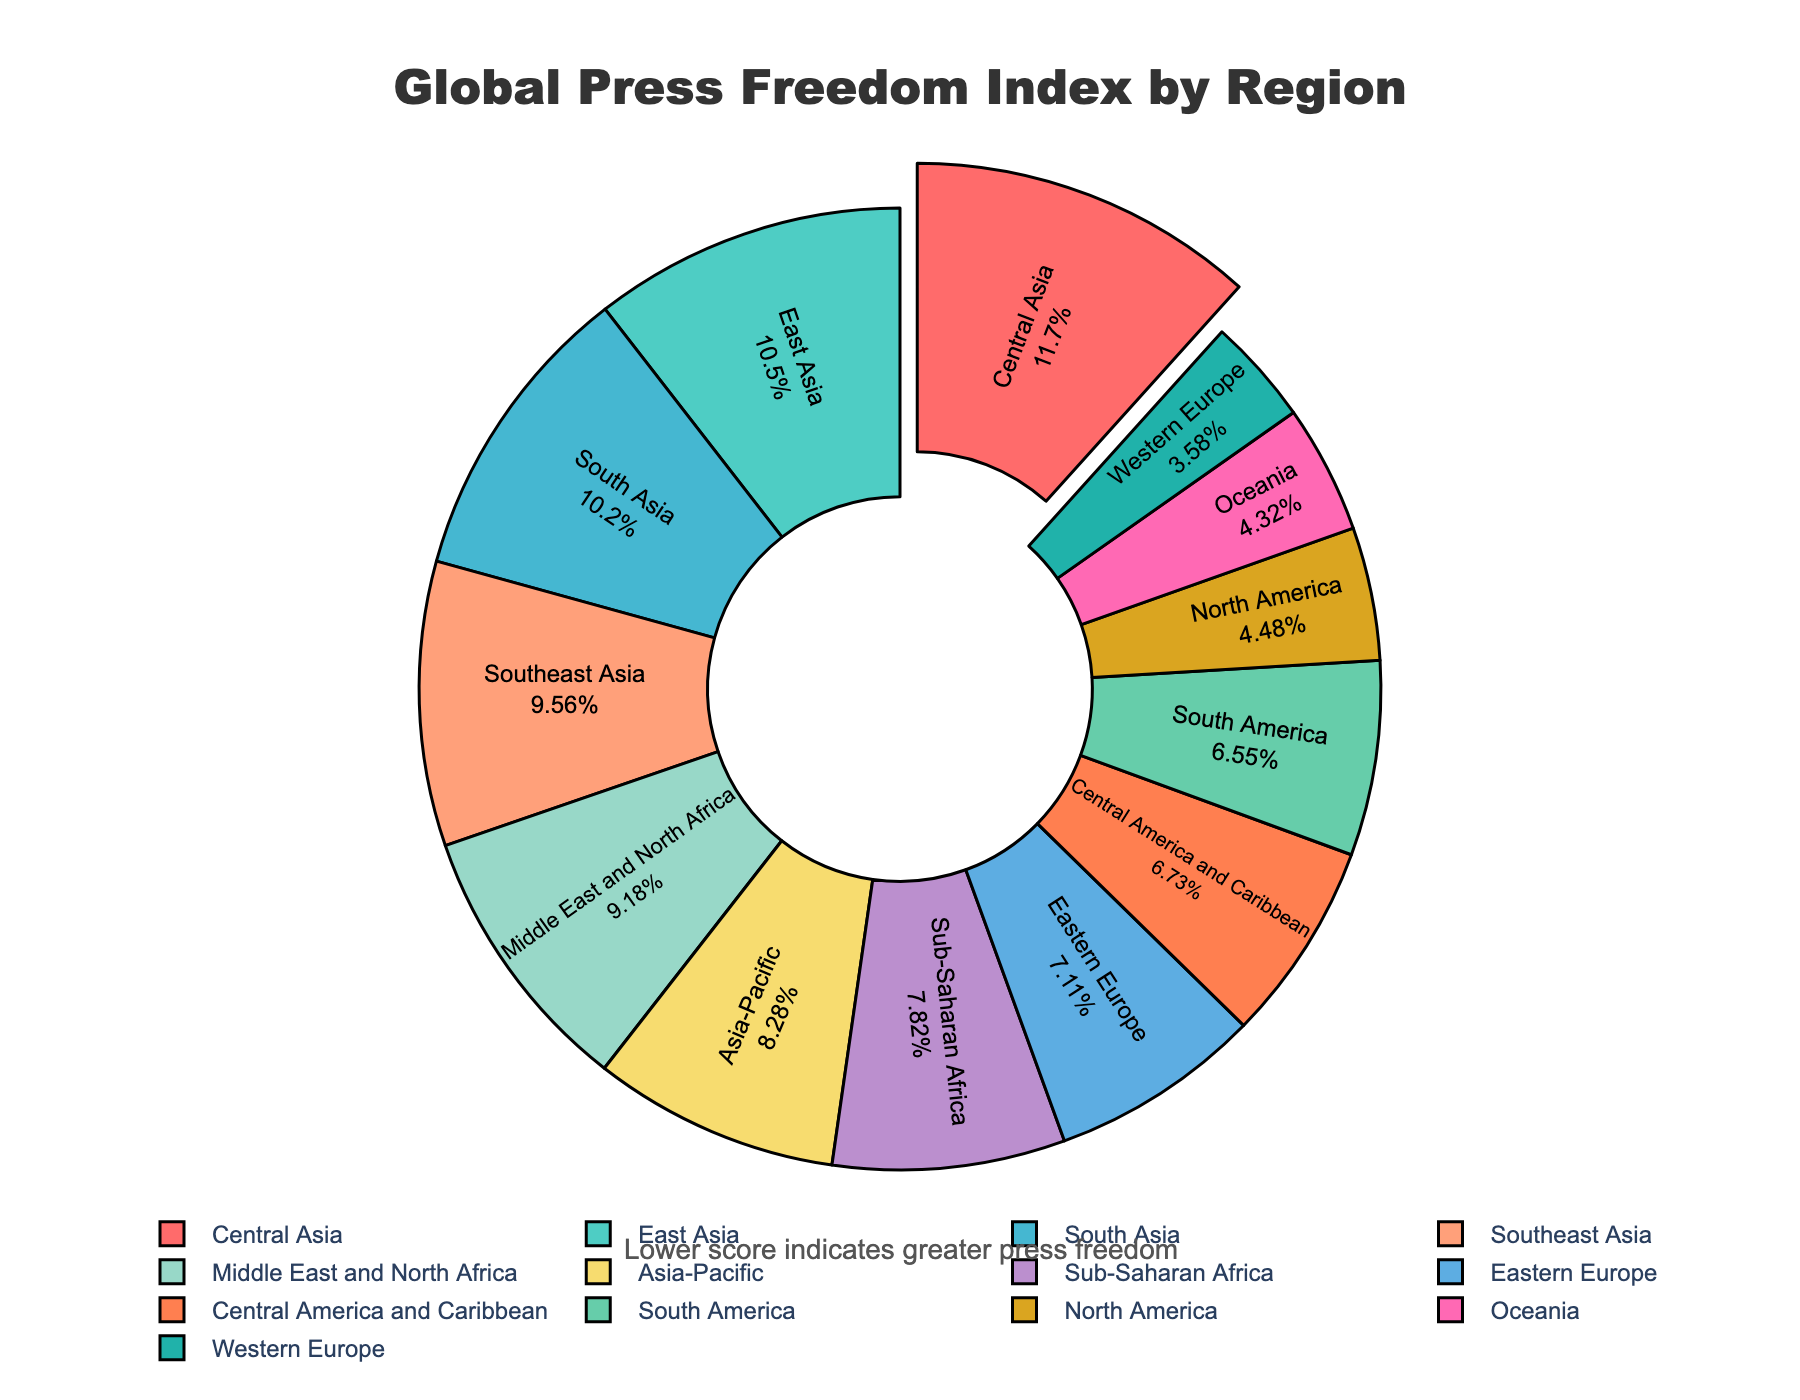Which region has the worst press freedom according to the index? Central Asia has the highest Press Freedom Score on the chart. The region with the highest Press Freedom Score indicates the worst press freedom.
Answer: Central Asia Which regions have better press freedom scores than North America? To answer this, we compare the Press Freedom Scores of other regions with North America's score (22.3). Western Europe and Oceania have lower scores, indicating better press freedom.
Answer: Western Europe, Oceania Calculate the average Press Freedom Score of regions in Asia (Central Asia, Southeast Asia, East Asia, South Asia). First, sum the Press Freedom Scores of the regions: 58.1 (Central Asia) + 47.6 (Southeast Asia) + 52.3 (East Asia) + 50.8 (South Asia) = 208.8. Then, divide by the number of regions: 208.8 / 4 = 52.2.
Answer: 52.2 Which region constitutes the largest percentage in the pie chart? Central Asia has the highest Press Freedom Score which translates to the largest percentage in the pie chart.
Answer: Central Asia What is the Press Freedom Score difference between Western Europe and Sub-Saharan Africa? Western Europe's score is 17.8, and Sub-Saharan Africa's score is 38.9. The difference can be calculated as 38.9 - 17.8 = 21.1.
Answer: 21.1 Compare the press freedom between the Americas (North America, South America, Central America and Caribbean). Which has the highest score? Among the Americas, compare the Press Freedom Scores: North America (22.3), South America (32.6), Central America, and Caribbean (33.5). Central America and Caribbean have the highest score.
Answer: Central America and Caribbean How much lower is Oceania's Press Freedom Score compared to South Asia's Press Freedom Score? Oceania's score is 21.5, and South Asia's score is 50.8. The difference is 50.8 - 21.5 = 29.3.
Answer: 29.3 What is the sum of Press Freedom Scores for the Middle East and North Africa and Eastern Europe? Middle East and North Africa's score is 45.7, and Eastern Europe's score is 35.4. The sum is 45.7 + 35.4 = 81.1.
Answer: 81.1 Is the Press Freedom Score of Western Europe the lowest among all the regions? Yes, Western Europe has a score of 17.8, which is the lowest Press Freedom Score among all listed regions.
Answer: Yes 